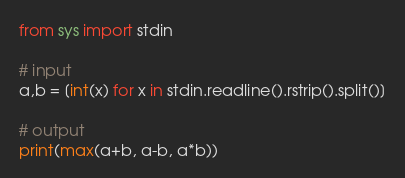<code> <loc_0><loc_0><loc_500><loc_500><_Python_>from sys import stdin

# input
a,b = [int(x) for x in stdin.readline().rstrip().split()]

# output
print(max(a+b, a-b, a*b))
</code> 